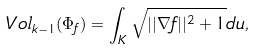Convert formula to latex. <formula><loc_0><loc_0><loc_500><loc_500>V o l _ { k - 1 } ( \Phi _ { f } ) = \int _ { K } \sqrt { | | \nabla f | | ^ { 2 } + 1 } d u ,</formula> 